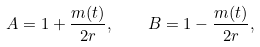<formula> <loc_0><loc_0><loc_500><loc_500>A = 1 + \frac { m ( t ) } { 2 r } , \quad B = 1 - \frac { m ( t ) } { 2 r } ,</formula> 